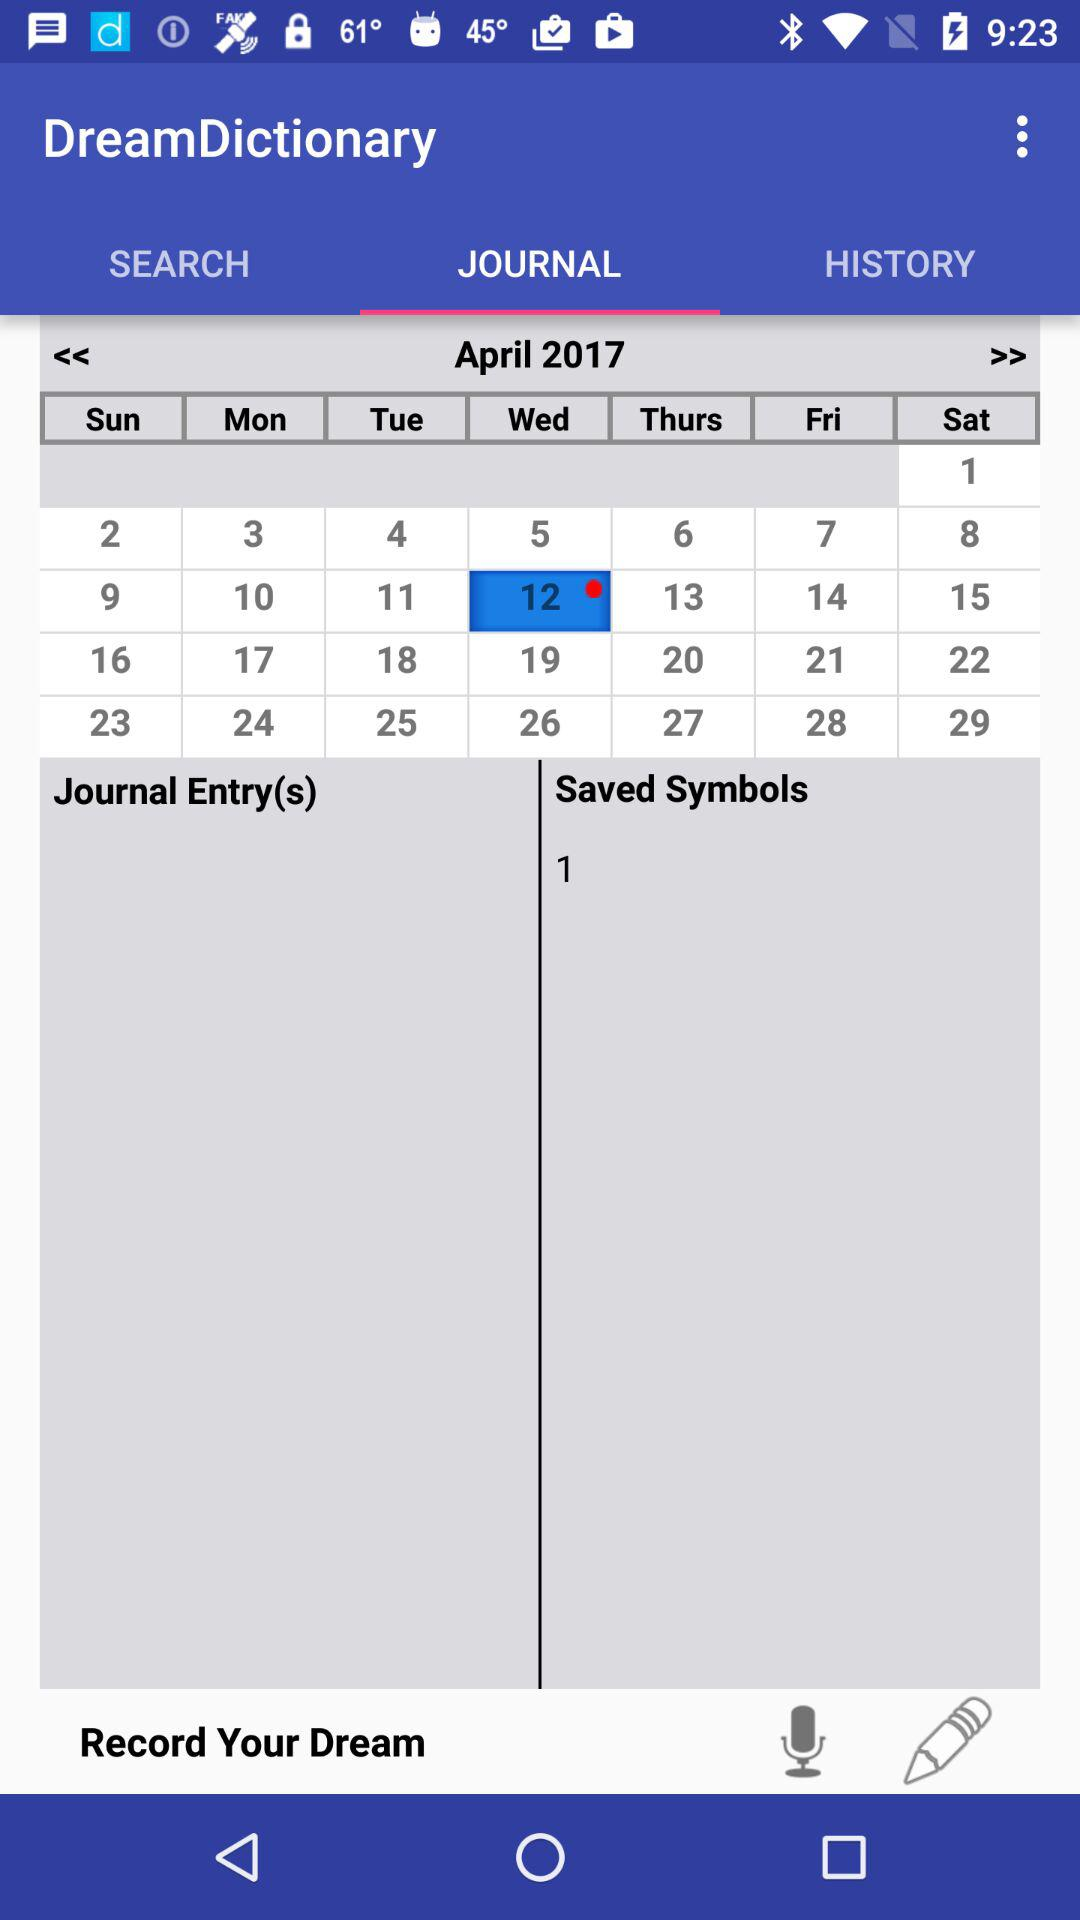What is the number showing in "Saved Symbols"? The number is 1. 